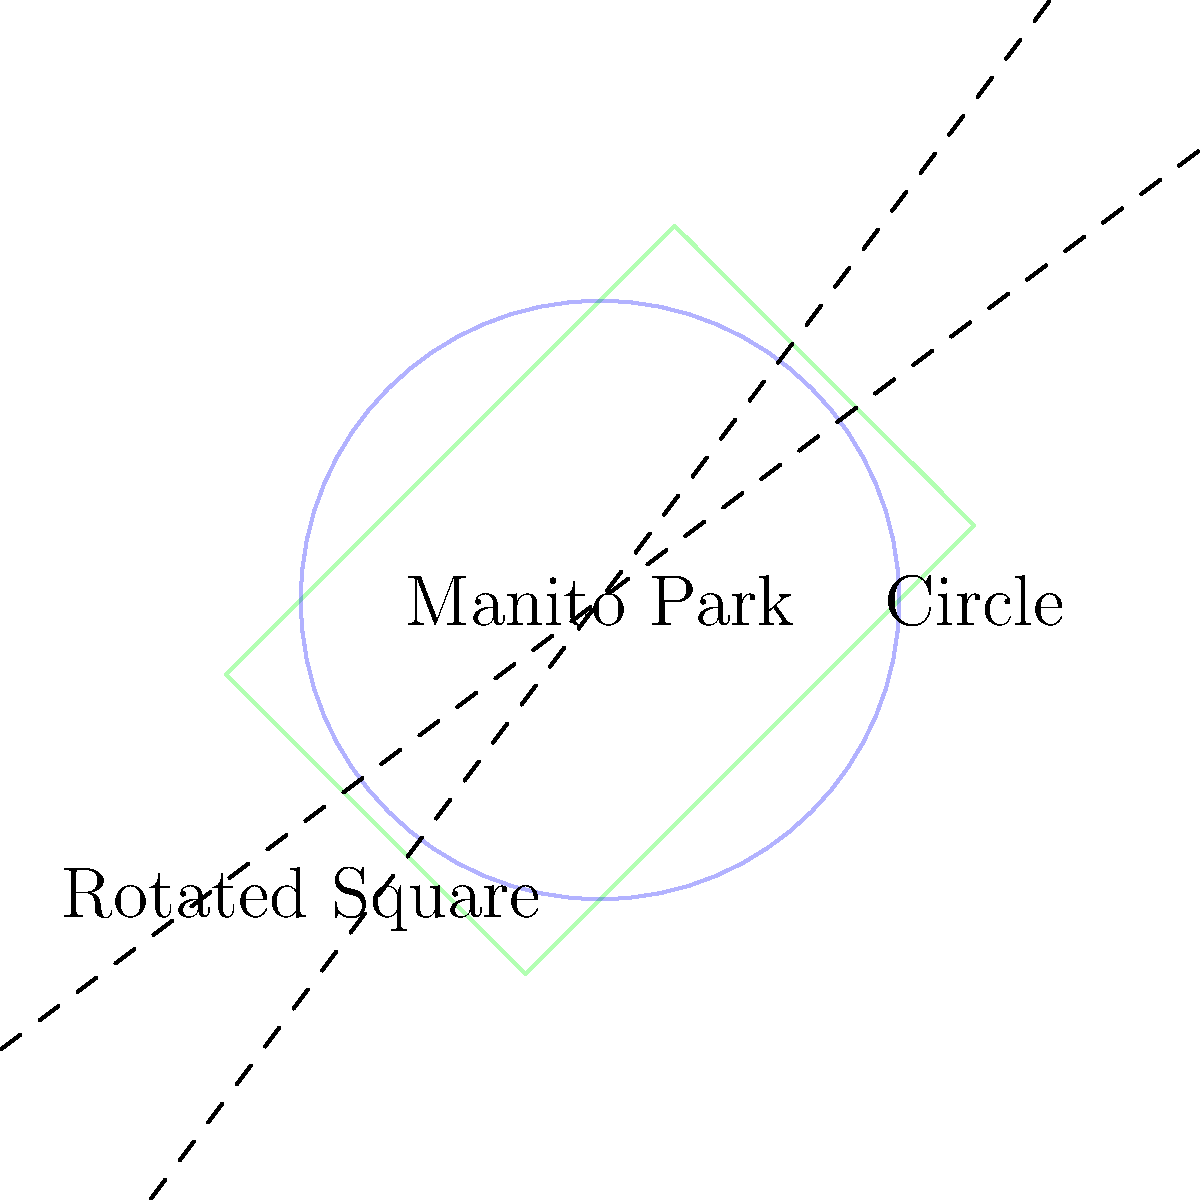Manito Park in the Cliff/Cannon neighborhood can be approximated as a rotated square. If a circle with a radius of 0.5 miles fits inside the park as shown, estimate the area of Manito Park in square miles. To estimate the area of Manito Park, we'll follow these steps:

1) The circle inside the park has a radius of 0.5 miles. Let's call the side length of the square $s$.

2) The diameter of the circle (1 mile) is equal to the side length of the square before rotation. So, $s = 1$ mile.

3) The area of a square is given by the formula $A = s^2$. 

4) Substituting $s = 1$ into the formula:
   $A = 1^2 = 1$ square mile

5) However, this is the area of the square before rotation. The rotation doesn't change the area.

Therefore, the estimated area of Manito Park is approximately 1 square mile.
Answer: 1 square mile 